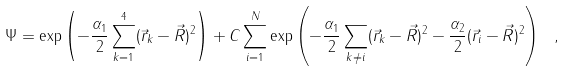<formula> <loc_0><loc_0><loc_500><loc_500>\Psi = \exp \left ( - \frac { \alpha _ { 1 } } { 2 } \sum _ { k = 1 } ^ { 4 } ( \vec { r } _ { k } - \vec { R } ) ^ { 2 } \right ) + C \sum _ { i = 1 } ^ { N } \exp \left ( - \frac { \alpha _ { 1 } } { 2 } \sum _ { k \neq i } ( \vec { r } _ { k } - \vec { R } ) ^ { 2 } - \frac { \alpha _ { 2 } } { 2 } ( \vec { r } _ { i } - \vec { R } ) ^ { 2 } \right ) \ ,</formula> 